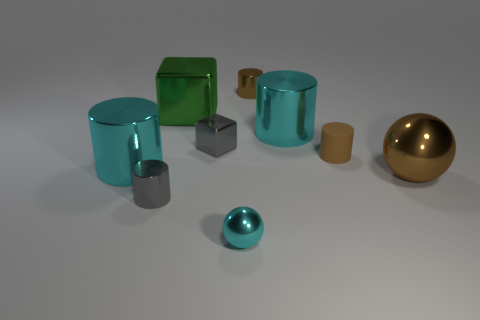Add 1 rubber things. How many objects exist? 10 Subtract all small shiny cylinders. How many cylinders are left? 3 Subtract all gray cylinders. How many cylinders are left? 4 Subtract 2 blocks. How many blocks are left? 0 Subtract all blocks. How many objects are left? 7 Add 1 small red objects. How many small red objects exist? 1 Subtract 0 red cylinders. How many objects are left? 9 Subtract all yellow spheres. Subtract all cyan cylinders. How many spheres are left? 2 Subtract all brown blocks. How many brown spheres are left? 1 Subtract all gray things. Subtract all tiny brown metallic objects. How many objects are left? 6 